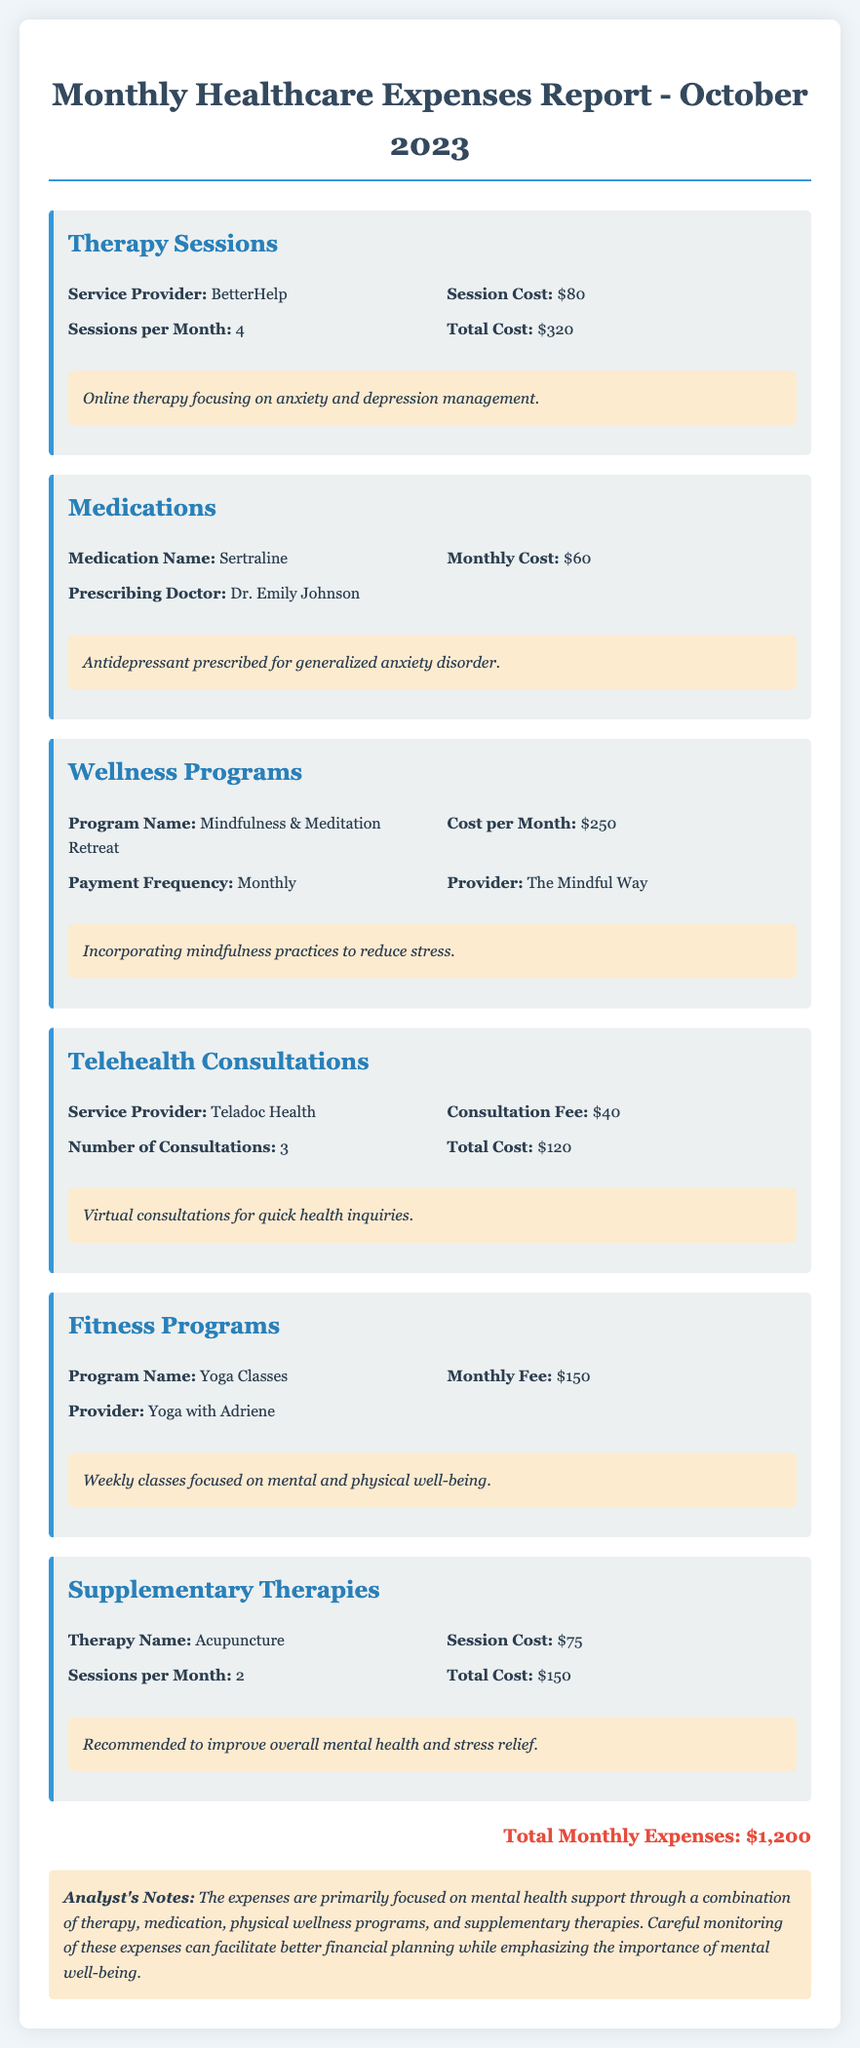What is the total cost for therapy sessions? The total cost for therapy sessions is specified as $320 in the expense category.
Answer: $320 How many yoga classes are included in the fitness programs? While the monthly fee for yoga classes is provided, the exact number of classes is not explicitly stated; however, it can be inferred that they are weekly, suggesting 4 classes.
Answer: 4 Who is the prescribing doctor for the medication? The report lists Dr. Emily Johnson as the prescribing doctor for the medication Sertraline.
Answer: Dr. Emily Johnson What is the monthly cost for the Mindfulness & Meditation Retreat? The document indicates that the cost per month for the wellness program is $250.
Answer: $250 What is the total monthly expense reported? Total monthly expenses are clearly stated at the bottom of the report as $1,200.
Answer: $1,200 Which service provider is associated with the telehealth consultations? The document mentions Teladoc Health as the service provider for telehealth consultations.
Answer: Teladoc Health What type of therapy is used to improve overall mental health? Acupuncture is identified as the therapy recommended to improve overall mental health and stress relief.
Answer: Acupuncture How often are therapy sessions held per month? The document specifies that there are 4 therapy sessions held per month.
Answer: 4 What is the session cost for acupuncture? The reported session cost for acupuncture is $75 per session.
Answer: $75 